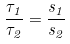Convert formula to latex. <formula><loc_0><loc_0><loc_500><loc_500>\frac { \tau _ { 1 } } { \tau _ { 2 } } = \frac { s _ { 1 } } { s _ { 2 } }</formula> 